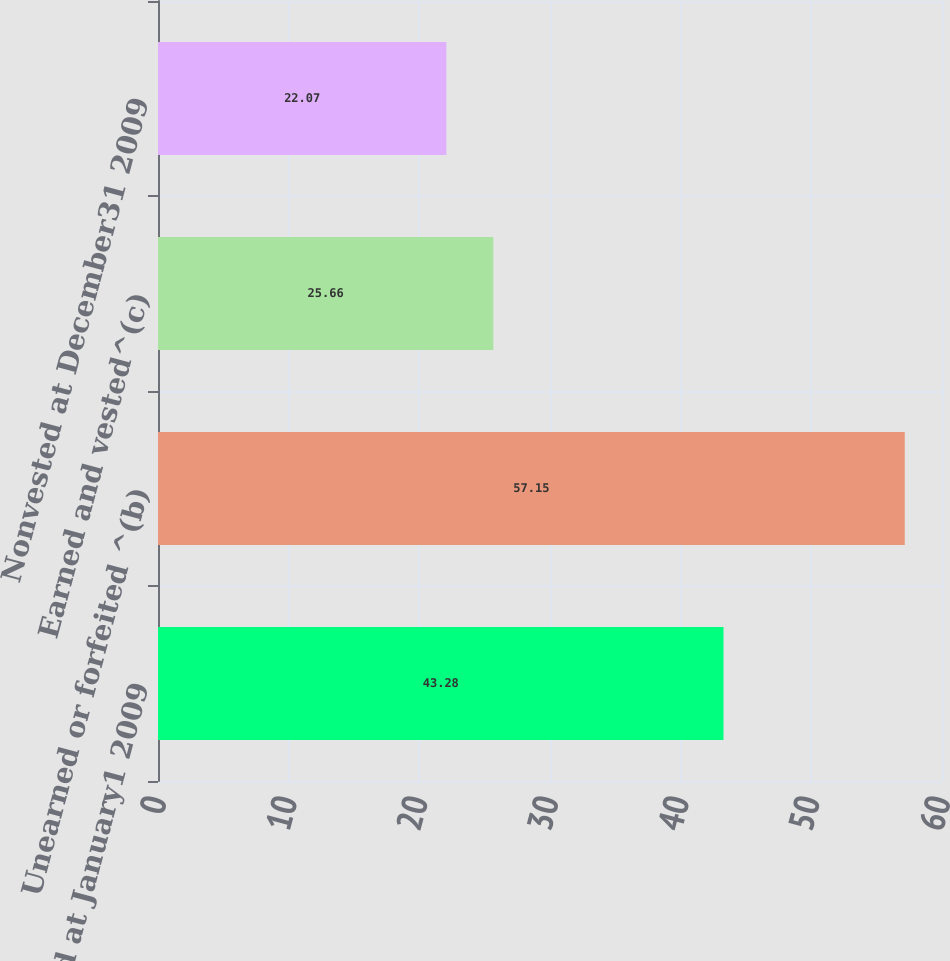Convert chart. <chart><loc_0><loc_0><loc_500><loc_500><bar_chart><fcel>Nonvested at January1 2009<fcel>Unearned or forfeited ^(b)<fcel>Earned and vested^(c)<fcel>Nonvested at December31 2009<nl><fcel>43.28<fcel>57.15<fcel>25.66<fcel>22.07<nl></chart> 